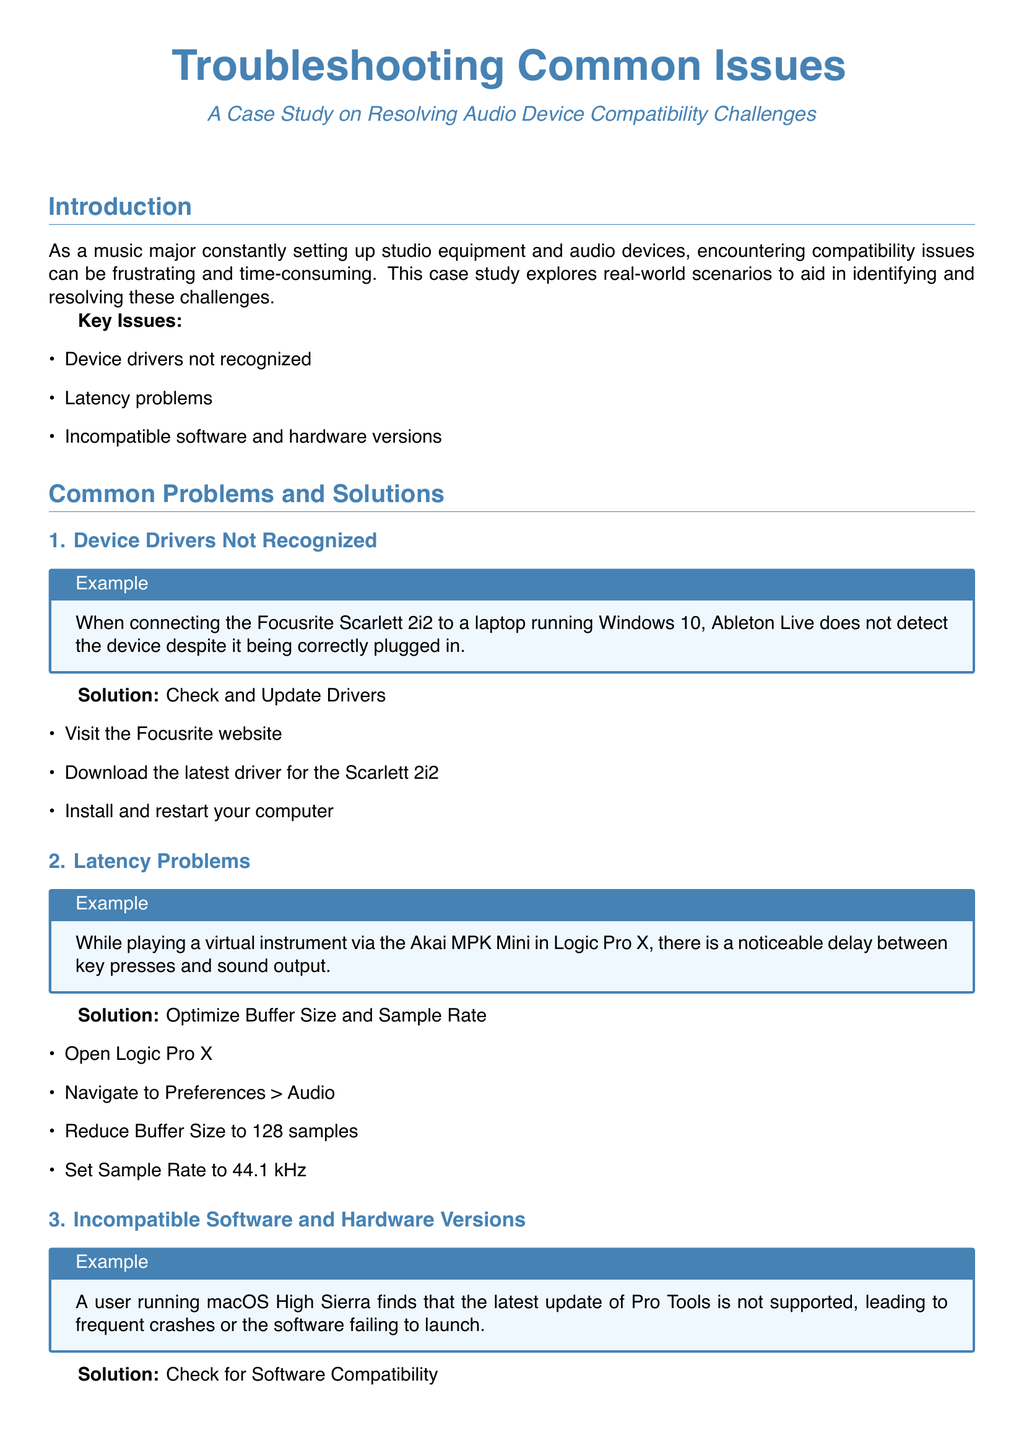What are the key issues addressed in the case study? The case study identifies three key issues related to audio device compatibility challenges: device drivers not recognized, latency problems, and incompatible software and hardware versions.
Answer: device drivers not recognized, latency problems, incompatible software and hardware versions What is the first example provided in the common problems section? The first example in the common problems section discusses a situation where the Focusrite Scarlett 2i2 is not detected by Ableton Live after being plugged in.
Answer: Focusrite Scarlett 2i2 not detected What should you do when device drivers are not recognized? The solution for device drivers not recognized includes visiting the manufacturer’s website to download and install the latest driver for the device.
Answer: Check and Update Drivers What is the recommended buffer size for reducing latency in Logic Pro X? In the case study, it is recommended to reduce the buffer size to 128 samples to improve the latency when using Logic Pro X.
Answer: 128 samples What is one recommended action to avoid software compatibility issues? The case study recommends regularly checking for updates from software and hardware manufacturers to prevent compatibility issues.
Answer: Regularly check for updates What problem is discussed concerning the Akai MPK Mini? The document discusses latency problems experienced while playing a virtual instrument via the Akai MPK Mini in Logic Pro X.
Answer: Latency problems How does the case study suggest solving the issue of incompatible software versions? The solution mentioned is to check the system requirements for the software version you are trying to use and either update macOS or revert to a compatible version of Pro Tools.
Answer: Check for Software Compatibility What is the purpose of the case study? The purpose of the case study is to explore real-world scenarios to aid in identifying and resolving audio device compatibility challenges.
Answer: Resolving audio device compatibility challenges What audio device is referenced as having driver issues? The Focusrite Scarlett 2i2 is mentioned as the audio device that faces driver recognition issues in the case study.
Answer: Focusrite Scarlett 2i2 What is suggested to keep your creative process flowing smoothly? One suggestion given is to maintain a list of troubleshooting steps to quickly solve issues when they arise.
Answer: Maintain a list of troubleshooting steps 